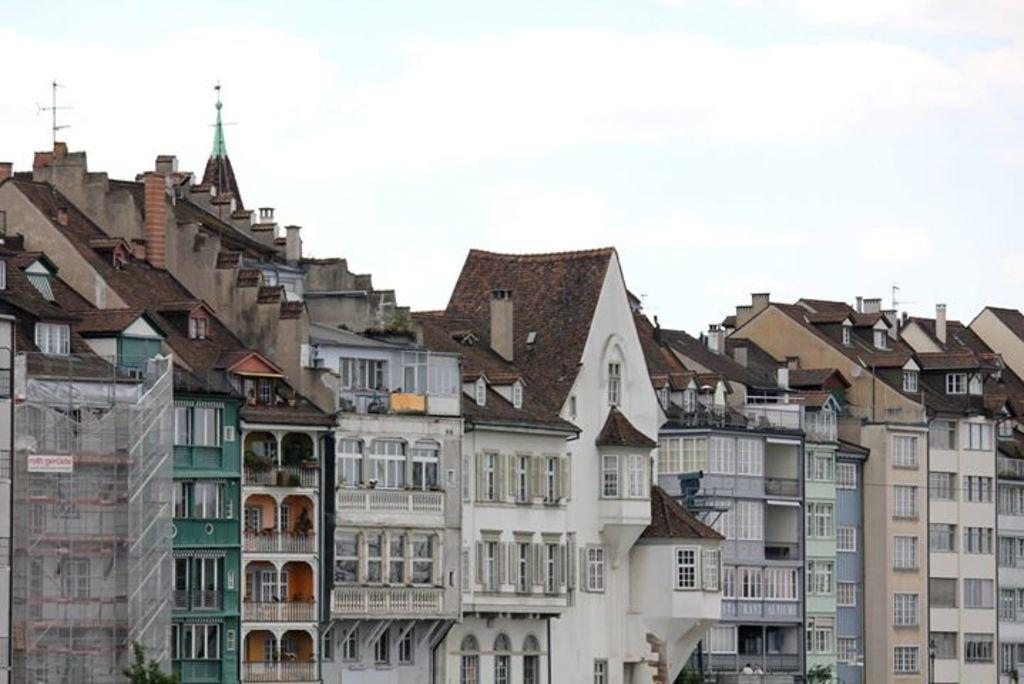What type of structures are present in the image? There are many buildings in the image. What are some features of the buildings? The buildings have walls, windows, balconies, and roofs. Are there any additional elements on top of the buildings? Yes, there are antennas on the top of the buildings. What is visible at the top of the image? The sky is visible at the top of the image. What grade of chalk is being used to draw on the front of the building in the image? There is no chalk or drawing present on the front of the building in the image. 